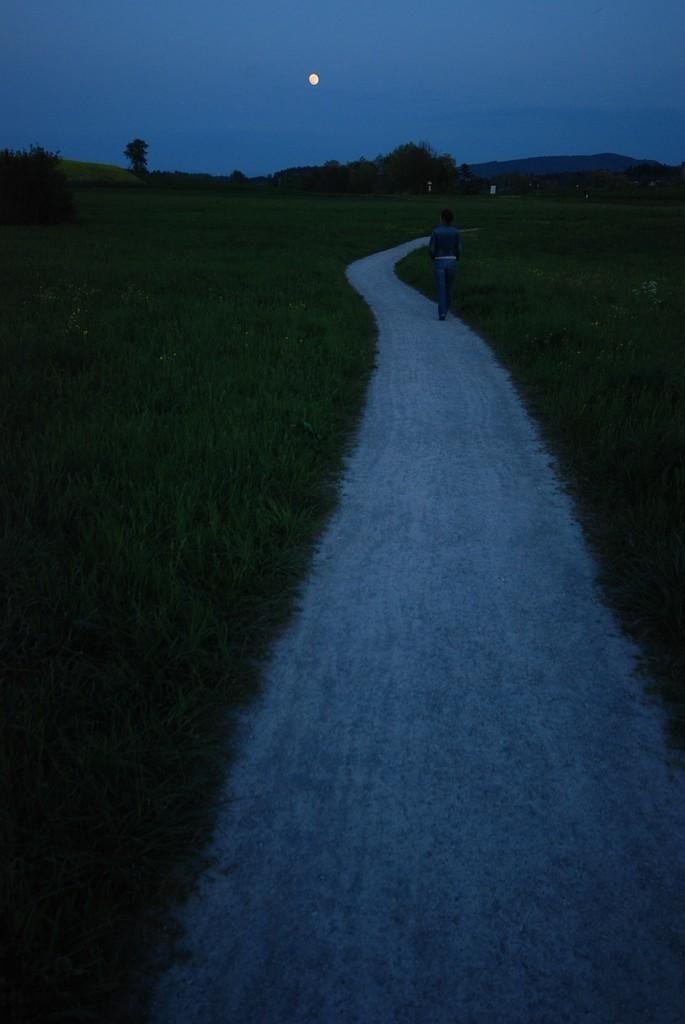What can be seen in the foreground of the image? There is a path and greenery in the foreground of the image. Is there anyone present in the image? Yes, there is a person in the image. What type of vegetation is visible in the image? There are trees in the image. Can you describe the background of the image? It appears that there are people in the background of the image, and the moon is visible in the sky. Where is the drawer located in the image? There is no drawer present in the image. What type of plant is being watered by the person in the image? There is no plant being watered in the image; the person is simply walking along the path. 